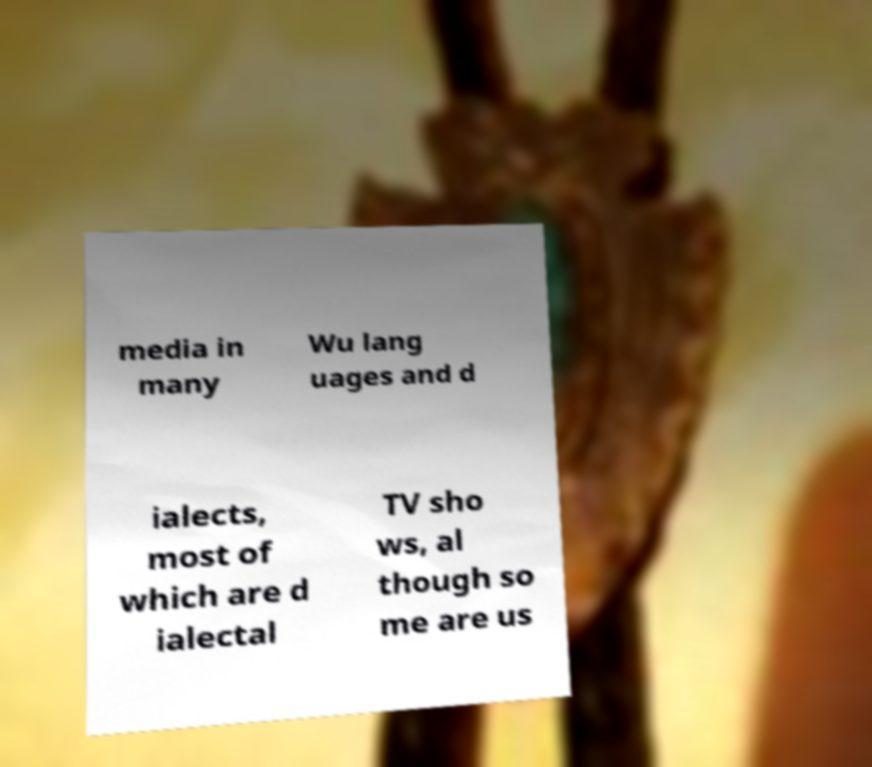For documentation purposes, I need the text within this image transcribed. Could you provide that? media in many Wu lang uages and d ialects, most of which are d ialectal TV sho ws, al though so me are us 